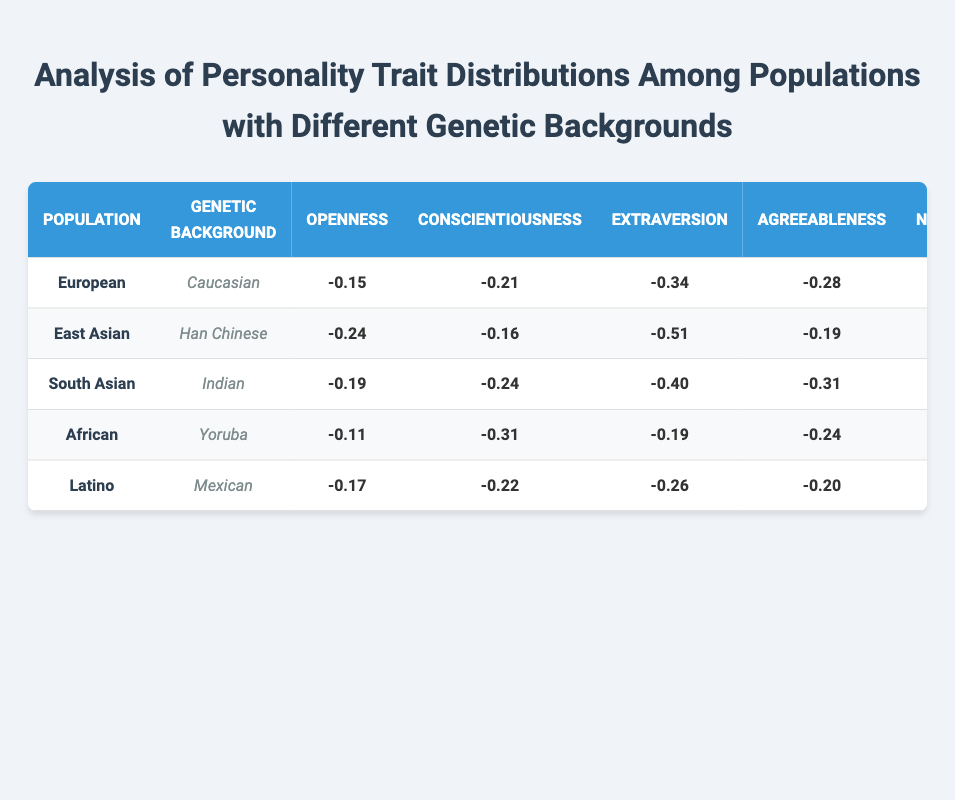What is the value of conscientiousness for the East Asian population? The table shows the conscientiousness value for the East Asian population, which is listed as -0.31 under the corresponding row.
Answer: -0.31 Which population has the highest score in openness? By examining the values in the openness column, the African population (Yoruba) has the highest score at -0.22.
Answer: -0.22 What is the difference in neuroticism between the European and South Asian populations? The neuroticism value for Europeans is -0.80 and for South Asians is -0.60. To find the difference, subtract -0.60 from -0.80, which equals -0.80 - (-0.60) = -0.20.
Answer: -0.20 Is the average openness value across all populations greater than -0.4? To find the average, add the openness values: (-0.29) + (-0.43) + (-0.36) + (-0.22) + (-0.33) = -1.63. Then divide by 5 (the number of populations), which results in -1.63 / 5 = -0.326. Since -0.326 is greater than -0.4, the answer is yes.
Answer: Yes Which population shows the lowest score in extraversion, and what is that value? Looking at the extraversion column, East Asian population has the lowest value of -0.69.
Answer: East Asian; -0.69 What is the median value of conscientiousness for the populations? First, list the conscientiousness values in order: -0.51, -0.43, -0.39, -0.40, -0.31. The middle value (median) is -0.39 since there are five values.
Answer: -0.39 